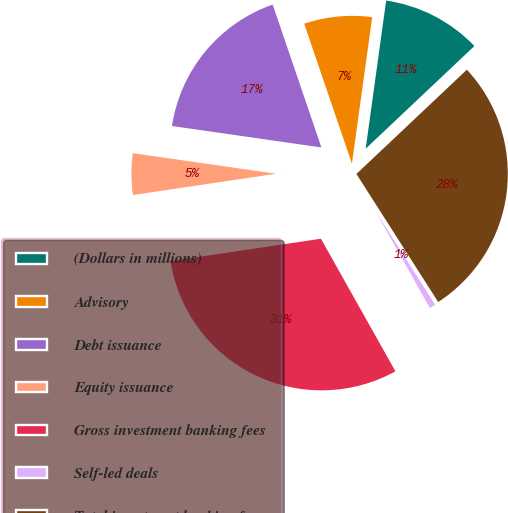Convert chart. <chart><loc_0><loc_0><loc_500><loc_500><pie_chart><fcel>(Dollars in millions)<fcel>Advisory<fcel>Debt issuance<fcel>Equity issuance<fcel>Gross investment banking fees<fcel>Self-led deals<fcel>Total investment banking fees<nl><fcel>10.77%<fcel>7.42%<fcel>17.5%<fcel>4.62%<fcel>30.8%<fcel>0.9%<fcel>28.0%<nl></chart> 